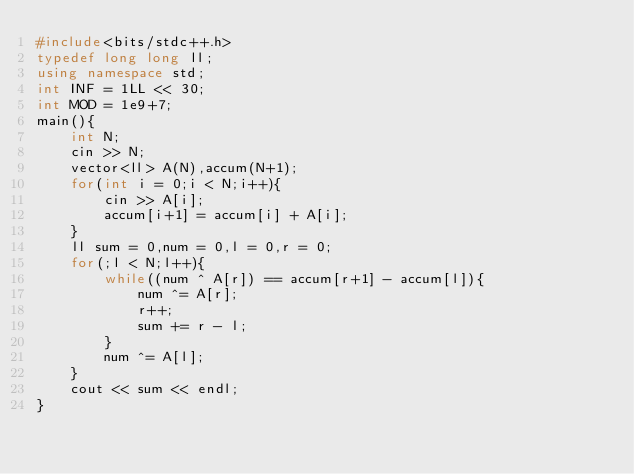Convert code to text. <code><loc_0><loc_0><loc_500><loc_500><_C++_>#include<bits/stdc++.h>
typedef long long ll;
using namespace std;
int INF = 1LL << 30;
int MOD = 1e9+7;
main(){
    int N;
    cin >> N;
    vector<ll> A(N),accum(N+1);
    for(int i = 0;i < N;i++){
        cin >> A[i];
        accum[i+1] = accum[i] + A[i];
    }
    ll sum = 0,num = 0,l = 0,r = 0;
    for(;l < N;l++){
        while((num ^ A[r]) == accum[r+1] - accum[l]){   
            num ^= A[r];
            r++;
            sum += r - l;
        }
        num ^= A[l];
    }
    cout << sum << endl;
}</code> 